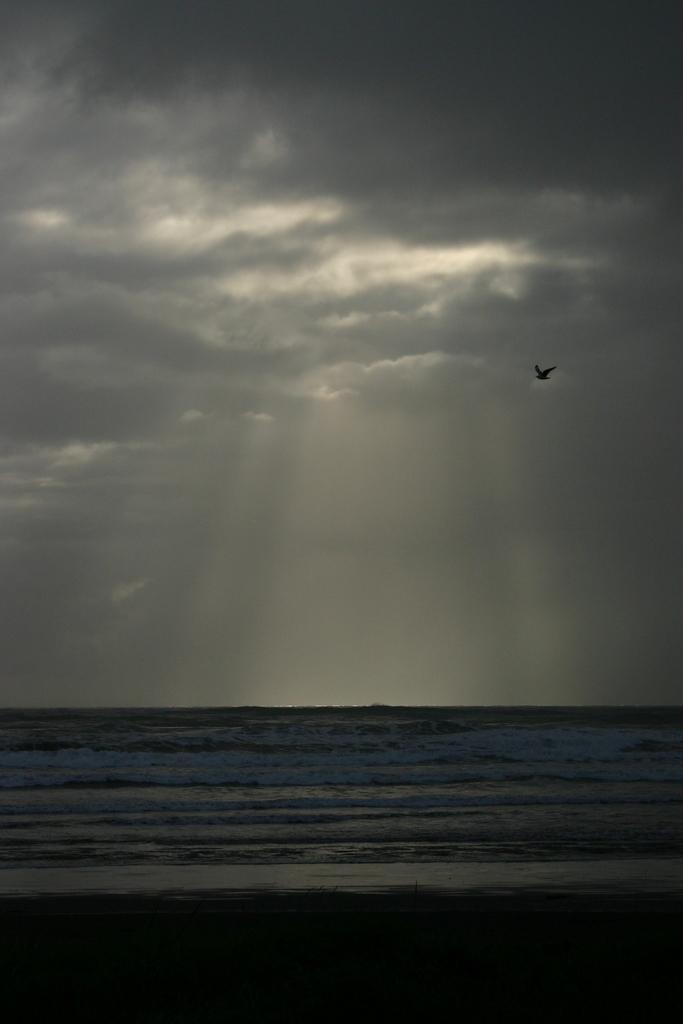What type of natural body of water is present in the image? There is a sea in the image. What animal can be seen in the image? A bird is flying in the image. What part of the environment is visible in the background of the image? The sky is visible in the background of the image. What type of disgust can be seen on the bird's face in the image? There is no indication of any emotion, including disgust, on the bird's face in the image. Can you tell me how many beans are present in the image? There are no beans present in the image. 